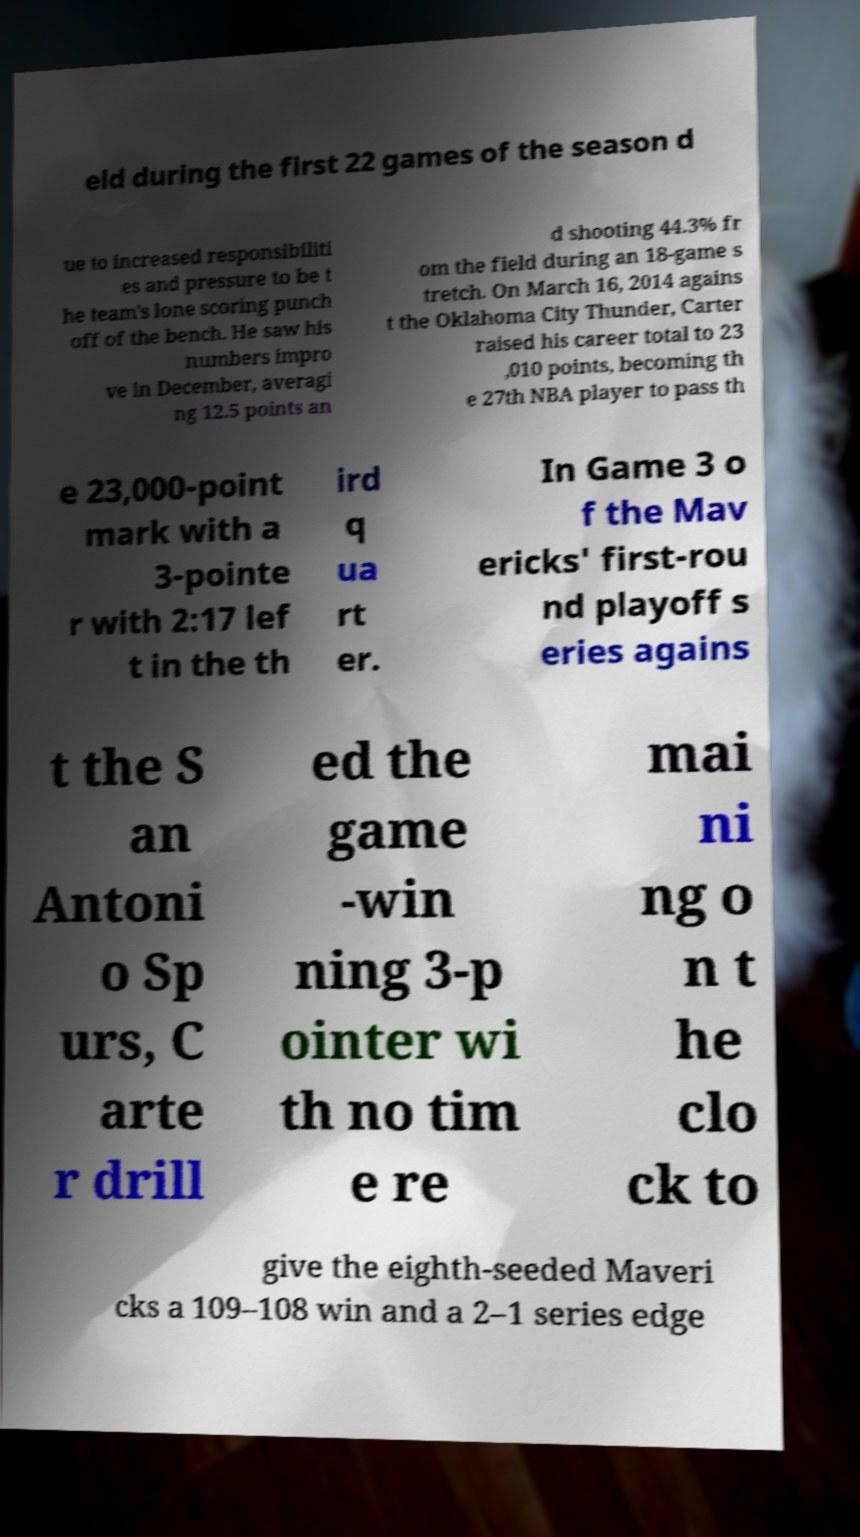For documentation purposes, I need the text within this image transcribed. Could you provide that? eld during the first 22 games of the season d ue to increased responsibiliti es and pressure to be t he team's lone scoring punch off of the bench. He saw his numbers impro ve in December, averagi ng 12.5 points an d shooting 44.3% fr om the field during an 18-game s tretch. On March 16, 2014 agains t the Oklahoma City Thunder, Carter raised his career total to 23 ,010 points, becoming th e 27th NBA player to pass th e 23,000-point mark with a 3-pointe r with 2:17 lef t in the th ird q ua rt er. In Game 3 o f the Mav ericks' first-rou nd playoff s eries agains t the S an Antoni o Sp urs, C arte r drill ed the game -win ning 3-p ointer wi th no tim e re mai ni ng o n t he clo ck to give the eighth-seeded Maveri cks a 109–108 win and a 2–1 series edge 